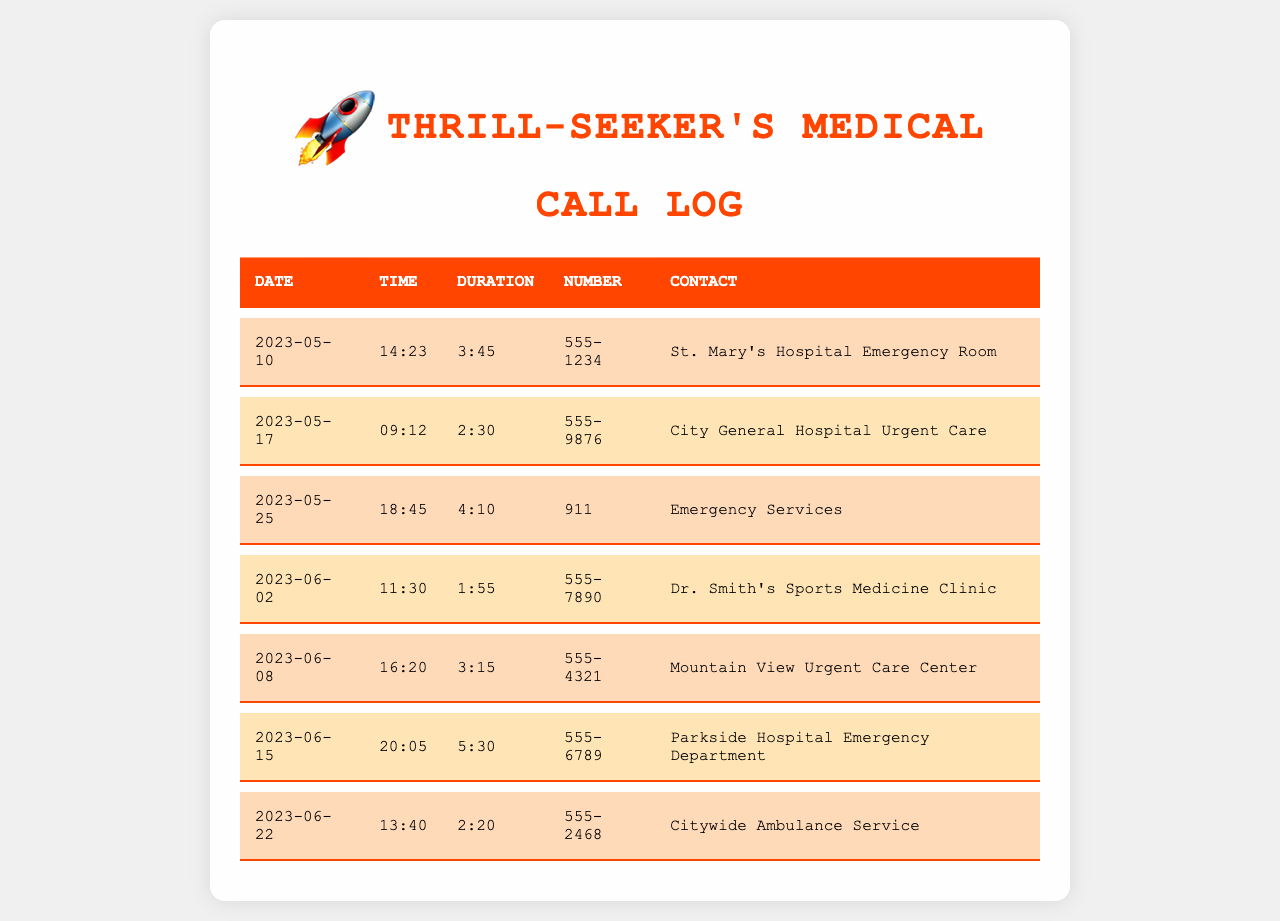What is the date of the first call? The first call in the log is dated May 10, 2023.
Answer: May 10, 2023 How long did the call to City General Hospital Urgent Care last? The duration of the call to City General Hospital Urgent Care on May 17, 2023, was 2 minutes and 30 seconds.
Answer: 2:30 Which contact was called on June 15, 2023? The contact called on June 15, 2023, was Parkside Hospital Emergency Department.
Answer: Parkside Hospital Emergency Department How many calls were made to emergency services? There are two calls listed that were made to emergency services.
Answer: 2 What was the contact number for Dr. Smith's Sports Medicine Clinic? The contact number for Dr. Smith's Sports Medicine Clinic is 555-7890.
Answer: 555-7890 Which hospital had the shortest call duration? The shortest call duration in the document was to Dr. Smith's Sports Medicine Clinic at 1 minute and 55 seconds.
Answer: 1:55 What is the total number of calls recorded? The document contains a total of seven calls.
Answer: 7 What time was the call to the Emergency Services? The call to Emergency Services was made at 18:45.
Answer: 18:45 